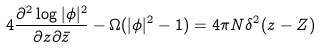<formula> <loc_0><loc_0><loc_500><loc_500>4 \frac { \partial ^ { 2 } \log | \phi | ^ { 2 } } { \partial z \partial { \bar { z } } } - \Omega ( | \phi | ^ { 2 } - 1 ) = 4 \pi N \delta ^ { 2 } ( z - Z )</formula> 